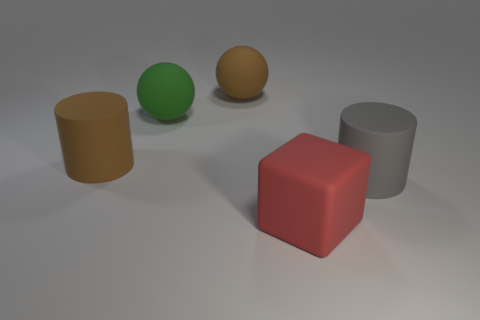Add 4 tiny things. How many objects exist? 9 Subtract all cylinders. How many objects are left? 3 Add 1 large metallic cylinders. How many large metallic cylinders exist? 1 Subtract 0 green cylinders. How many objects are left? 5 Subtract all green rubber objects. Subtract all yellow matte objects. How many objects are left? 4 Add 2 large brown rubber balls. How many large brown rubber balls are left? 3 